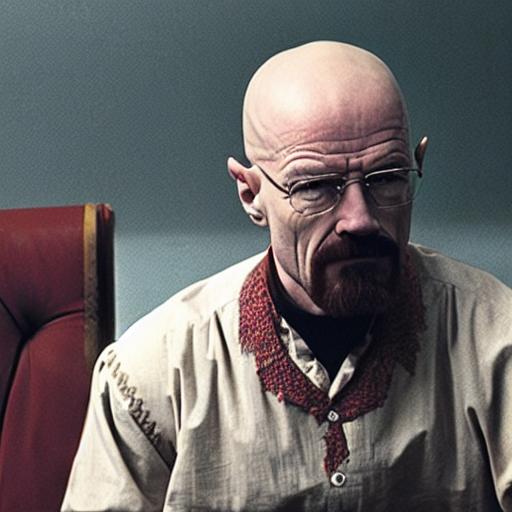What can you tell about the character based on their attire? The character's attire, a buttoned-up shirt with an earthy toned vest, exudes a working-class aura, resonating with themes of practicality and a no-nonsense approach to life's trials. 